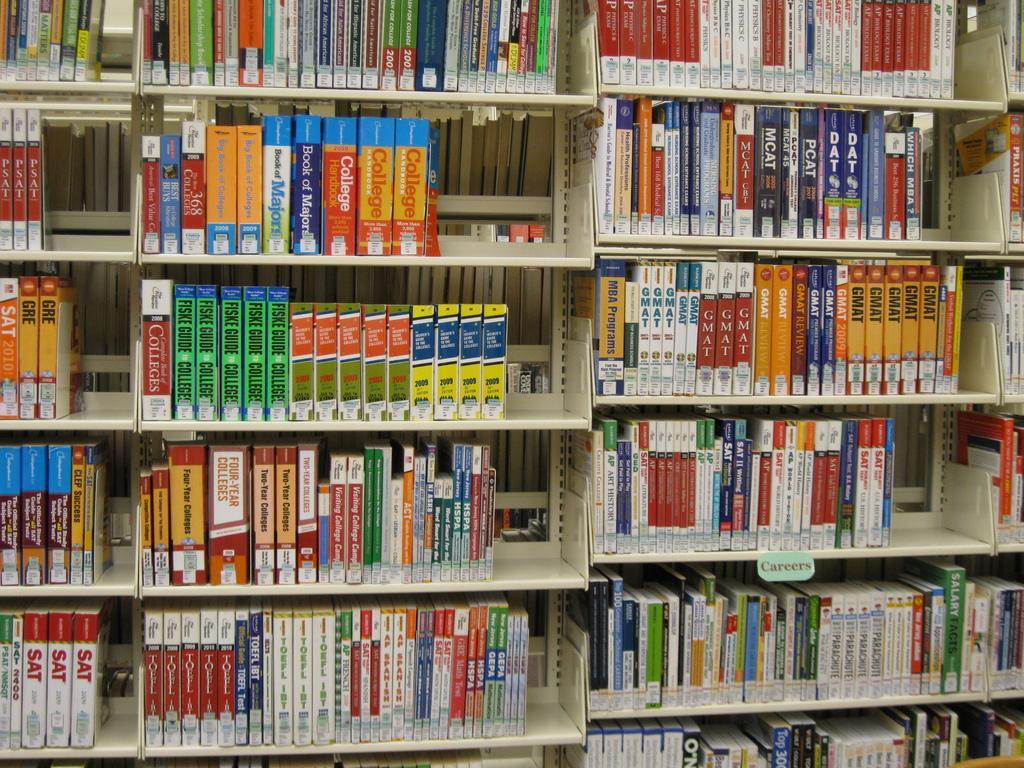Can you describe this image briefly? In the image we can see there are lot of books kept in a bookshelf. 